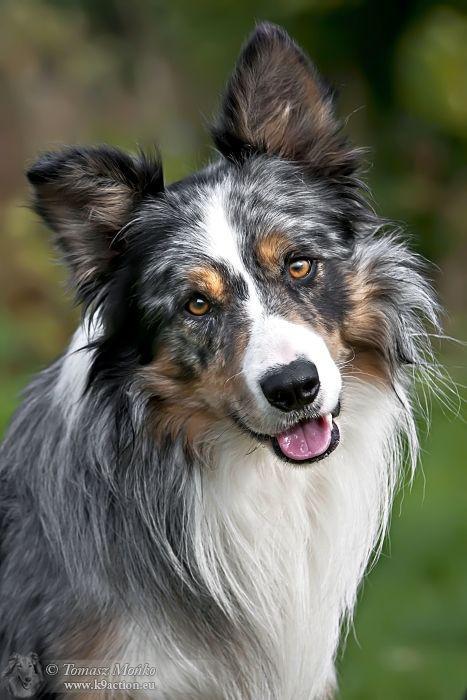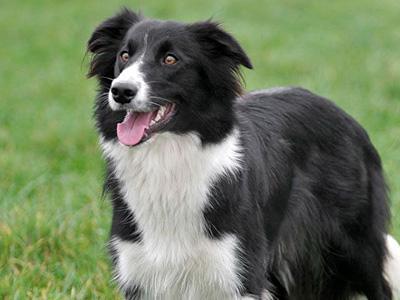The first image is the image on the left, the second image is the image on the right. Given the left and right images, does the statement "The coat of the dog on the right is black and white only." hold true? Answer yes or no. Yes. 